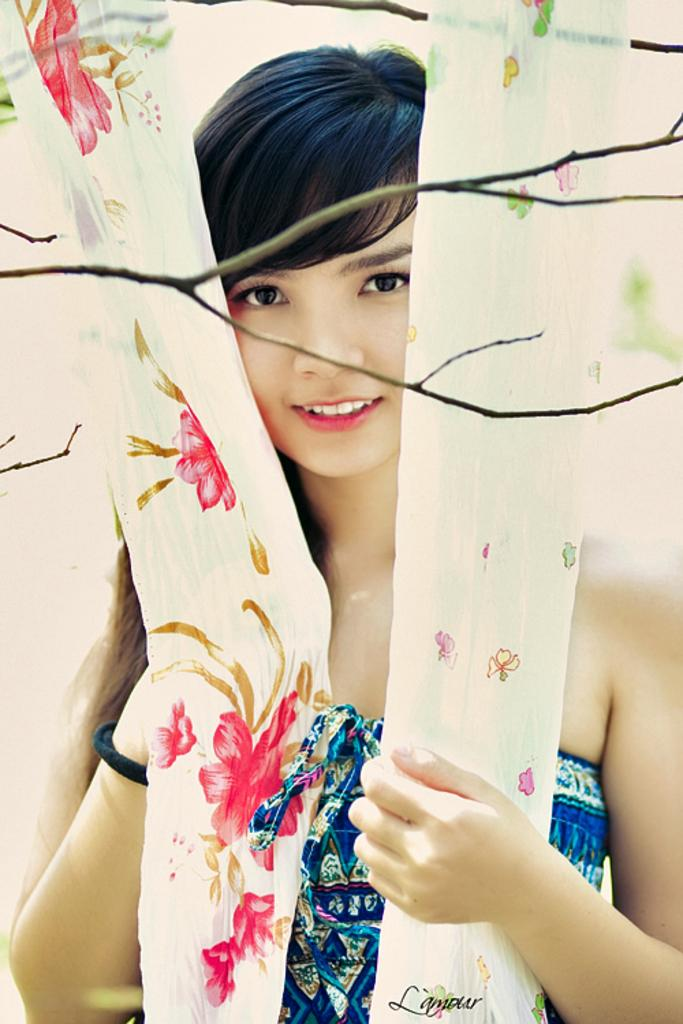What is the appearance of the woman in the image? There is a beautiful woman in the image. What is the woman wearing? The woman is wearing a blue dress. Are there any accessories visible on the woman? Yes, the woman has a black band on her wrist. What is the woman's expression in the image? The woman is smiling. What can be seen in the background of the image? There are colorful curtains and twigs visible in the image. What type of band is playing in the image? There is no band playing in the image; it features a woman wearing a black band on her wrist. Can you see a cannon in the image? No, there is no cannon present in the image. 